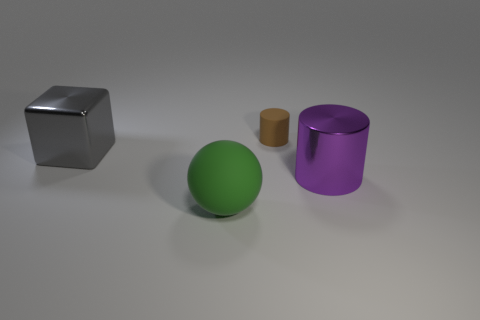Add 2 green matte objects. How many objects exist? 6 Subtract 2 cylinders. How many cylinders are left? 0 Subtract all brown cylinders. How many cylinders are left? 1 Subtract all cubes. How many objects are left? 3 Subtract all big gray shiny things. Subtract all big matte spheres. How many objects are left? 2 Add 1 large green spheres. How many large green spheres are left? 2 Add 1 large purple things. How many large purple things exist? 2 Subtract 0 gray balls. How many objects are left? 4 Subtract all gray cylinders. Subtract all brown spheres. How many cylinders are left? 2 